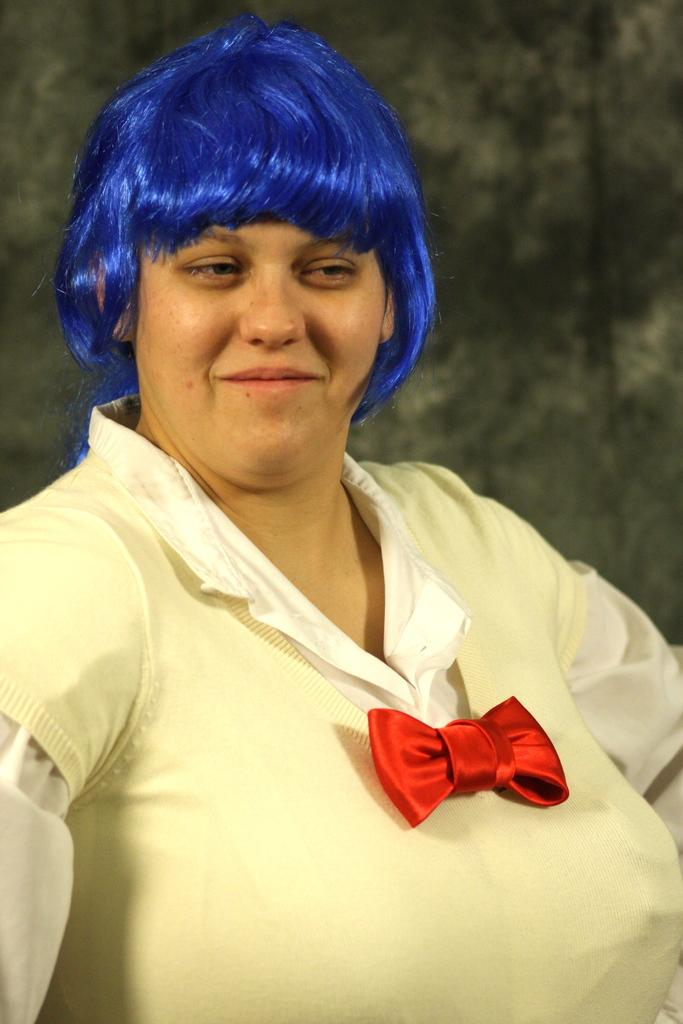What is the main subject of the image? There is a person in the image. Can you describe the setting or environment in the image? There is a background in the image. What type of ship can be seen in the background of the image? There is no ship present in the image; the background does not include any maritime elements. 